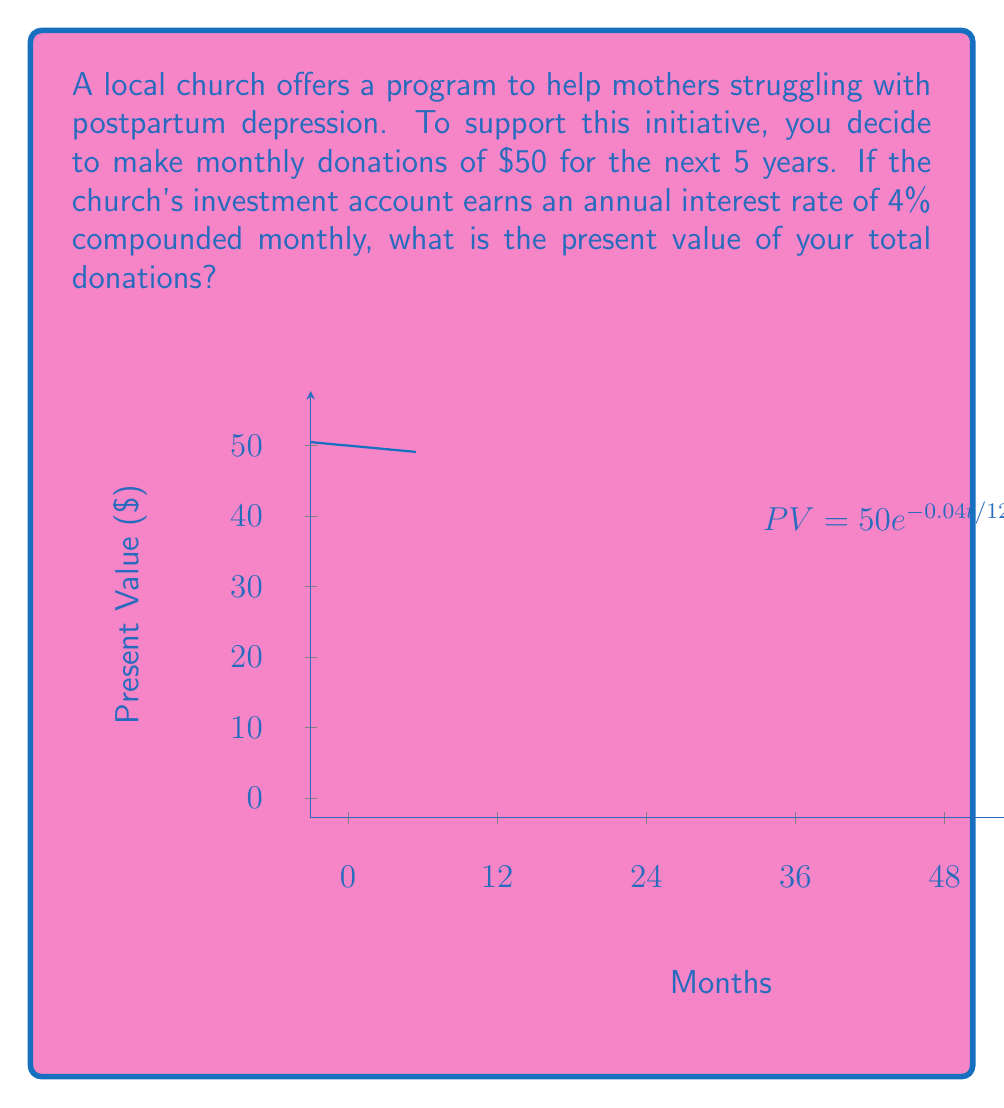Solve this math problem. Let's approach this step-by-step:

1) We need to use the present value formula for an annuity:

   $$PV = PMT \cdot \frac{1 - (1 + r)^{-n}}{r}$$

   Where:
   PV = Present Value
   PMT = Regular Payment Amount
   r = Interest rate per period
   n = Number of periods

2) Given information:
   - Monthly donation (PMT) = $50
   - Annual interest rate = 4% = 0.04
   - Compounding frequency = Monthly
   - Time period = 5 years = 60 months

3) Calculate the monthly interest rate:
   $$r = \frac{0.04}{12} = 0.0033333$$

4) Now we can plug in the values:
   $$PV = 50 \cdot \frac{1 - (1 + 0.0033333)^{-60}}{0.0033333}$$

5) Using a calculator or computer:
   $$PV = 50 \cdot 53.6442$$
   $$PV = 2682.21$$

Therefore, the present value of your donations is $2,682.21.
Answer: $2,682.21 